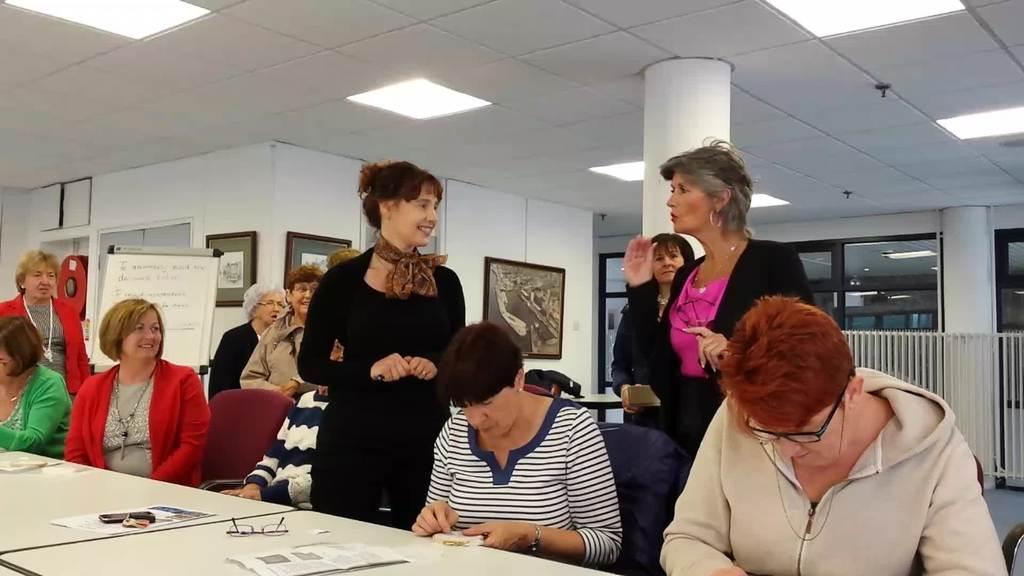How would you summarize this image in a sentence or two? There are group of people sitting on the table at the right side of the image there is a person who is speaking to the other person who is on the middle of the image at the left side of the image there is a board and paintings on the wall at the right side of the image there is a fencing 